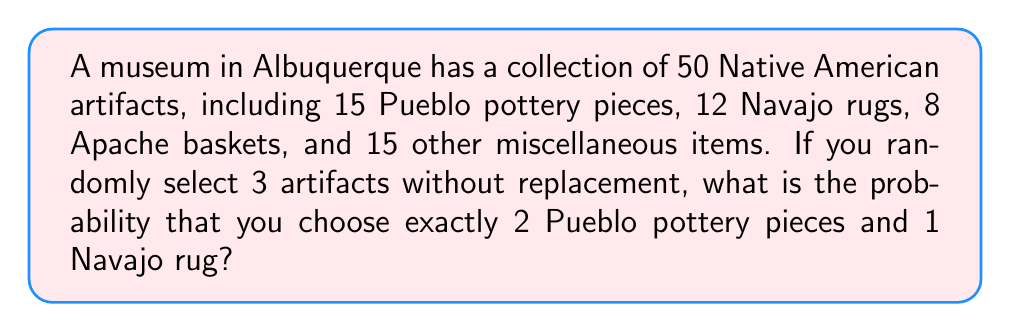Could you help me with this problem? Let's approach this step-by-step using the principles of combinatorics:

1) First, we need to calculate the total number of ways to select 3 artifacts out of 50. This can be done using the combination formula:

   $$\binom{50}{3} = \frac{50!}{3!(50-3)!} = \frac{50!}{3!47!} = 19,600$$

2) Now, we need to calculate the number of ways to select 2 Pueblo pottery pieces out of 15 and 1 Navajo rug out of 12:

   $$\binom{15}{2} \times \binom{12}{1} = \frac{15!}{2!13!} \times \frac{12!}{1!11!} = 105 \times 12 = 1,260$$

3) The probability is the number of favorable outcomes divided by the total number of possible outcomes:

   $$P(\text{2 Pueblo pottery, 1 Navajo rug}) = \frac{1,260}{19,600} = \frac{63}{980} \approx 0.0643$$
Answer: $\frac{63}{980}$ 